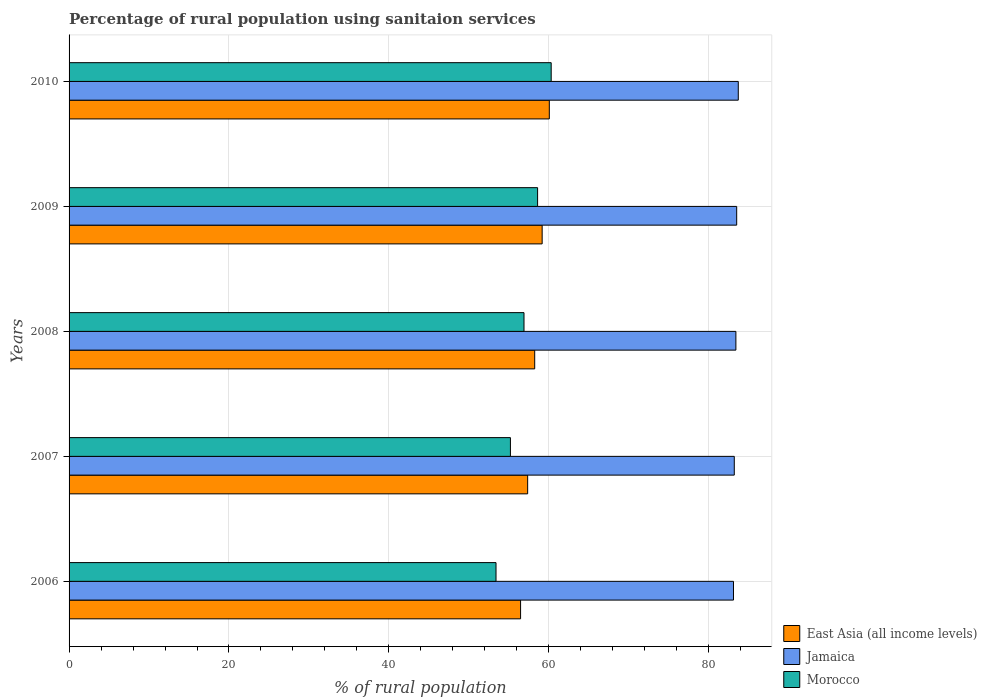How many different coloured bars are there?
Provide a succinct answer. 3. Are the number of bars on each tick of the Y-axis equal?
Give a very brief answer. Yes. How many bars are there on the 5th tick from the top?
Your response must be concise. 3. How many bars are there on the 4th tick from the bottom?
Ensure brevity in your answer.  3. In how many cases, is the number of bars for a given year not equal to the number of legend labels?
Your response must be concise. 0. What is the percentage of rural population using sanitaion services in Morocco in 2007?
Make the answer very short. 55.2. Across all years, what is the maximum percentage of rural population using sanitaion services in East Asia (all income levels)?
Your answer should be very brief. 60.07. Across all years, what is the minimum percentage of rural population using sanitaion services in East Asia (all income levels)?
Your answer should be compact. 56.47. In which year was the percentage of rural population using sanitaion services in Morocco maximum?
Give a very brief answer. 2010. What is the total percentage of rural population using sanitaion services in East Asia (all income levels) in the graph?
Make the answer very short. 291.3. What is the difference between the percentage of rural population using sanitaion services in Jamaica in 2006 and that in 2009?
Provide a short and direct response. -0.4. What is the difference between the percentage of rural population using sanitaion services in Morocco in 2009 and the percentage of rural population using sanitaion services in Jamaica in 2008?
Offer a terse response. -24.8. What is the average percentage of rural population using sanitaion services in Jamaica per year?
Provide a short and direct response. 83.38. In the year 2009, what is the difference between the percentage of rural population using sanitaion services in East Asia (all income levels) and percentage of rural population using sanitaion services in Morocco?
Offer a terse response. 0.57. In how many years, is the percentage of rural population using sanitaion services in Morocco greater than 16 %?
Your answer should be compact. 5. What is the ratio of the percentage of rural population using sanitaion services in Jamaica in 2007 to that in 2010?
Ensure brevity in your answer.  0.99. Is the percentage of rural population using sanitaion services in Jamaica in 2007 less than that in 2010?
Ensure brevity in your answer.  Yes. Is the difference between the percentage of rural population using sanitaion services in East Asia (all income levels) in 2006 and 2009 greater than the difference between the percentage of rural population using sanitaion services in Morocco in 2006 and 2009?
Offer a terse response. Yes. What is the difference between the highest and the second highest percentage of rural population using sanitaion services in East Asia (all income levels)?
Ensure brevity in your answer.  0.9. What is the difference between the highest and the lowest percentage of rural population using sanitaion services in Morocco?
Keep it short and to the point. 6.9. In how many years, is the percentage of rural population using sanitaion services in Morocco greater than the average percentage of rural population using sanitaion services in Morocco taken over all years?
Give a very brief answer. 3. Is the sum of the percentage of rural population using sanitaion services in East Asia (all income levels) in 2006 and 2010 greater than the maximum percentage of rural population using sanitaion services in Jamaica across all years?
Your answer should be compact. Yes. What does the 2nd bar from the top in 2010 represents?
Provide a succinct answer. Jamaica. What does the 1st bar from the bottom in 2008 represents?
Ensure brevity in your answer.  East Asia (all income levels). How many bars are there?
Give a very brief answer. 15. How many years are there in the graph?
Give a very brief answer. 5. Are the values on the major ticks of X-axis written in scientific E-notation?
Keep it short and to the point. No. Does the graph contain grids?
Offer a terse response. Yes. Where does the legend appear in the graph?
Provide a succinct answer. Bottom right. What is the title of the graph?
Give a very brief answer. Percentage of rural population using sanitaion services. Does "Low income" appear as one of the legend labels in the graph?
Your answer should be very brief. No. What is the label or title of the X-axis?
Ensure brevity in your answer.  % of rural population. What is the % of rural population of East Asia (all income levels) in 2006?
Make the answer very short. 56.47. What is the % of rural population in Jamaica in 2006?
Your response must be concise. 83.1. What is the % of rural population in Morocco in 2006?
Make the answer very short. 53.4. What is the % of rural population in East Asia (all income levels) in 2007?
Your answer should be very brief. 57.36. What is the % of rural population of Jamaica in 2007?
Your answer should be very brief. 83.2. What is the % of rural population of Morocco in 2007?
Provide a short and direct response. 55.2. What is the % of rural population of East Asia (all income levels) in 2008?
Provide a short and direct response. 58.24. What is the % of rural population of Jamaica in 2008?
Offer a terse response. 83.4. What is the % of rural population in Morocco in 2008?
Your answer should be very brief. 56.9. What is the % of rural population in East Asia (all income levels) in 2009?
Make the answer very short. 59.17. What is the % of rural population of Jamaica in 2009?
Your response must be concise. 83.5. What is the % of rural population of Morocco in 2009?
Offer a very short reply. 58.6. What is the % of rural population of East Asia (all income levels) in 2010?
Give a very brief answer. 60.07. What is the % of rural population in Jamaica in 2010?
Offer a terse response. 83.7. What is the % of rural population in Morocco in 2010?
Your answer should be compact. 60.3. Across all years, what is the maximum % of rural population of East Asia (all income levels)?
Your answer should be compact. 60.07. Across all years, what is the maximum % of rural population in Jamaica?
Ensure brevity in your answer.  83.7. Across all years, what is the maximum % of rural population in Morocco?
Give a very brief answer. 60.3. Across all years, what is the minimum % of rural population in East Asia (all income levels)?
Make the answer very short. 56.47. Across all years, what is the minimum % of rural population of Jamaica?
Offer a very short reply. 83.1. Across all years, what is the minimum % of rural population in Morocco?
Make the answer very short. 53.4. What is the total % of rural population in East Asia (all income levels) in the graph?
Your response must be concise. 291.3. What is the total % of rural population of Jamaica in the graph?
Keep it short and to the point. 416.9. What is the total % of rural population of Morocco in the graph?
Give a very brief answer. 284.4. What is the difference between the % of rural population in East Asia (all income levels) in 2006 and that in 2007?
Offer a very short reply. -0.89. What is the difference between the % of rural population in East Asia (all income levels) in 2006 and that in 2008?
Provide a short and direct response. -1.77. What is the difference between the % of rural population of Jamaica in 2006 and that in 2008?
Provide a succinct answer. -0.3. What is the difference between the % of rural population of East Asia (all income levels) in 2006 and that in 2009?
Ensure brevity in your answer.  -2.7. What is the difference between the % of rural population of Jamaica in 2006 and that in 2009?
Ensure brevity in your answer.  -0.4. What is the difference between the % of rural population in Morocco in 2006 and that in 2009?
Offer a very short reply. -5.2. What is the difference between the % of rural population in East Asia (all income levels) in 2006 and that in 2010?
Provide a short and direct response. -3.59. What is the difference between the % of rural population in East Asia (all income levels) in 2007 and that in 2008?
Provide a short and direct response. -0.88. What is the difference between the % of rural population of East Asia (all income levels) in 2007 and that in 2009?
Your response must be concise. -1.81. What is the difference between the % of rural population in East Asia (all income levels) in 2007 and that in 2010?
Ensure brevity in your answer.  -2.71. What is the difference between the % of rural population in Jamaica in 2007 and that in 2010?
Make the answer very short. -0.5. What is the difference between the % of rural population in Morocco in 2007 and that in 2010?
Your response must be concise. -5.1. What is the difference between the % of rural population of East Asia (all income levels) in 2008 and that in 2009?
Give a very brief answer. -0.93. What is the difference between the % of rural population of Morocco in 2008 and that in 2009?
Keep it short and to the point. -1.7. What is the difference between the % of rural population in East Asia (all income levels) in 2008 and that in 2010?
Provide a succinct answer. -1.83. What is the difference between the % of rural population of East Asia (all income levels) in 2009 and that in 2010?
Offer a terse response. -0.9. What is the difference between the % of rural population in Jamaica in 2009 and that in 2010?
Offer a very short reply. -0.2. What is the difference between the % of rural population of East Asia (all income levels) in 2006 and the % of rural population of Jamaica in 2007?
Make the answer very short. -26.73. What is the difference between the % of rural population of East Asia (all income levels) in 2006 and the % of rural population of Morocco in 2007?
Your answer should be very brief. 1.27. What is the difference between the % of rural population of Jamaica in 2006 and the % of rural population of Morocco in 2007?
Your answer should be very brief. 27.9. What is the difference between the % of rural population of East Asia (all income levels) in 2006 and the % of rural population of Jamaica in 2008?
Provide a succinct answer. -26.93. What is the difference between the % of rural population in East Asia (all income levels) in 2006 and the % of rural population in Morocco in 2008?
Your answer should be very brief. -0.43. What is the difference between the % of rural population in Jamaica in 2006 and the % of rural population in Morocco in 2008?
Provide a succinct answer. 26.2. What is the difference between the % of rural population in East Asia (all income levels) in 2006 and the % of rural population in Jamaica in 2009?
Keep it short and to the point. -27.03. What is the difference between the % of rural population of East Asia (all income levels) in 2006 and the % of rural population of Morocco in 2009?
Your answer should be very brief. -2.13. What is the difference between the % of rural population of Jamaica in 2006 and the % of rural population of Morocco in 2009?
Your answer should be compact. 24.5. What is the difference between the % of rural population of East Asia (all income levels) in 2006 and the % of rural population of Jamaica in 2010?
Provide a short and direct response. -27.23. What is the difference between the % of rural population in East Asia (all income levels) in 2006 and the % of rural population in Morocco in 2010?
Your answer should be very brief. -3.83. What is the difference between the % of rural population of Jamaica in 2006 and the % of rural population of Morocco in 2010?
Offer a terse response. 22.8. What is the difference between the % of rural population in East Asia (all income levels) in 2007 and the % of rural population in Jamaica in 2008?
Make the answer very short. -26.04. What is the difference between the % of rural population of East Asia (all income levels) in 2007 and the % of rural population of Morocco in 2008?
Your answer should be very brief. 0.46. What is the difference between the % of rural population in Jamaica in 2007 and the % of rural population in Morocco in 2008?
Your response must be concise. 26.3. What is the difference between the % of rural population in East Asia (all income levels) in 2007 and the % of rural population in Jamaica in 2009?
Your answer should be compact. -26.14. What is the difference between the % of rural population in East Asia (all income levels) in 2007 and the % of rural population in Morocco in 2009?
Keep it short and to the point. -1.24. What is the difference between the % of rural population of Jamaica in 2007 and the % of rural population of Morocco in 2009?
Offer a very short reply. 24.6. What is the difference between the % of rural population in East Asia (all income levels) in 2007 and the % of rural population in Jamaica in 2010?
Ensure brevity in your answer.  -26.34. What is the difference between the % of rural population in East Asia (all income levels) in 2007 and the % of rural population in Morocco in 2010?
Keep it short and to the point. -2.94. What is the difference between the % of rural population of Jamaica in 2007 and the % of rural population of Morocco in 2010?
Give a very brief answer. 22.9. What is the difference between the % of rural population in East Asia (all income levels) in 2008 and the % of rural population in Jamaica in 2009?
Provide a succinct answer. -25.26. What is the difference between the % of rural population of East Asia (all income levels) in 2008 and the % of rural population of Morocco in 2009?
Make the answer very short. -0.36. What is the difference between the % of rural population of Jamaica in 2008 and the % of rural population of Morocco in 2009?
Keep it short and to the point. 24.8. What is the difference between the % of rural population of East Asia (all income levels) in 2008 and the % of rural population of Jamaica in 2010?
Provide a succinct answer. -25.46. What is the difference between the % of rural population in East Asia (all income levels) in 2008 and the % of rural population in Morocco in 2010?
Give a very brief answer. -2.06. What is the difference between the % of rural population of Jamaica in 2008 and the % of rural population of Morocco in 2010?
Make the answer very short. 23.1. What is the difference between the % of rural population of East Asia (all income levels) in 2009 and the % of rural population of Jamaica in 2010?
Offer a very short reply. -24.53. What is the difference between the % of rural population of East Asia (all income levels) in 2009 and the % of rural population of Morocco in 2010?
Your response must be concise. -1.13. What is the difference between the % of rural population of Jamaica in 2009 and the % of rural population of Morocco in 2010?
Your response must be concise. 23.2. What is the average % of rural population of East Asia (all income levels) per year?
Ensure brevity in your answer.  58.26. What is the average % of rural population of Jamaica per year?
Provide a succinct answer. 83.38. What is the average % of rural population in Morocco per year?
Your response must be concise. 56.88. In the year 2006, what is the difference between the % of rural population of East Asia (all income levels) and % of rural population of Jamaica?
Provide a succinct answer. -26.63. In the year 2006, what is the difference between the % of rural population in East Asia (all income levels) and % of rural population in Morocco?
Your response must be concise. 3.07. In the year 2006, what is the difference between the % of rural population in Jamaica and % of rural population in Morocco?
Your answer should be very brief. 29.7. In the year 2007, what is the difference between the % of rural population in East Asia (all income levels) and % of rural population in Jamaica?
Provide a short and direct response. -25.84. In the year 2007, what is the difference between the % of rural population in East Asia (all income levels) and % of rural population in Morocco?
Offer a very short reply. 2.16. In the year 2008, what is the difference between the % of rural population of East Asia (all income levels) and % of rural population of Jamaica?
Provide a short and direct response. -25.16. In the year 2008, what is the difference between the % of rural population in East Asia (all income levels) and % of rural population in Morocco?
Your response must be concise. 1.34. In the year 2008, what is the difference between the % of rural population in Jamaica and % of rural population in Morocco?
Your response must be concise. 26.5. In the year 2009, what is the difference between the % of rural population in East Asia (all income levels) and % of rural population in Jamaica?
Give a very brief answer. -24.33. In the year 2009, what is the difference between the % of rural population of East Asia (all income levels) and % of rural population of Morocco?
Provide a short and direct response. 0.57. In the year 2009, what is the difference between the % of rural population in Jamaica and % of rural population in Morocco?
Provide a succinct answer. 24.9. In the year 2010, what is the difference between the % of rural population in East Asia (all income levels) and % of rural population in Jamaica?
Give a very brief answer. -23.63. In the year 2010, what is the difference between the % of rural population in East Asia (all income levels) and % of rural population in Morocco?
Your response must be concise. -0.23. In the year 2010, what is the difference between the % of rural population of Jamaica and % of rural population of Morocco?
Provide a short and direct response. 23.4. What is the ratio of the % of rural population in East Asia (all income levels) in 2006 to that in 2007?
Provide a short and direct response. 0.98. What is the ratio of the % of rural population of Jamaica in 2006 to that in 2007?
Your response must be concise. 1. What is the ratio of the % of rural population of Morocco in 2006 to that in 2007?
Give a very brief answer. 0.97. What is the ratio of the % of rural population in East Asia (all income levels) in 2006 to that in 2008?
Ensure brevity in your answer.  0.97. What is the ratio of the % of rural population in Morocco in 2006 to that in 2008?
Make the answer very short. 0.94. What is the ratio of the % of rural population in East Asia (all income levels) in 2006 to that in 2009?
Keep it short and to the point. 0.95. What is the ratio of the % of rural population of Jamaica in 2006 to that in 2009?
Your answer should be compact. 1. What is the ratio of the % of rural population in Morocco in 2006 to that in 2009?
Make the answer very short. 0.91. What is the ratio of the % of rural population in East Asia (all income levels) in 2006 to that in 2010?
Give a very brief answer. 0.94. What is the ratio of the % of rural population of Morocco in 2006 to that in 2010?
Your answer should be compact. 0.89. What is the ratio of the % of rural population of East Asia (all income levels) in 2007 to that in 2008?
Make the answer very short. 0.98. What is the ratio of the % of rural population in Jamaica in 2007 to that in 2008?
Your answer should be very brief. 1. What is the ratio of the % of rural population in Morocco in 2007 to that in 2008?
Offer a very short reply. 0.97. What is the ratio of the % of rural population of East Asia (all income levels) in 2007 to that in 2009?
Your answer should be very brief. 0.97. What is the ratio of the % of rural population in Jamaica in 2007 to that in 2009?
Your response must be concise. 1. What is the ratio of the % of rural population in Morocco in 2007 to that in 2009?
Make the answer very short. 0.94. What is the ratio of the % of rural population of East Asia (all income levels) in 2007 to that in 2010?
Offer a terse response. 0.95. What is the ratio of the % of rural population in Morocco in 2007 to that in 2010?
Give a very brief answer. 0.92. What is the ratio of the % of rural population in East Asia (all income levels) in 2008 to that in 2009?
Make the answer very short. 0.98. What is the ratio of the % of rural population of East Asia (all income levels) in 2008 to that in 2010?
Offer a very short reply. 0.97. What is the ratio of the % of rural population of Jamaica in 2008 to that in 2010?
Offer a terse response. 1. What is the ratio of the % of rural population in Morocco in 2008 to that in 2010?
Ensure brevity in your answer.  0.94. What is the ratio of the % of rural population of East Asia (all income levels) in 2009 to that in 2010?
Ensure brevity in your answer.  0.99. What is the ratio of the % of rural population of Jamaica in 2009 to that in 2010?
Ensure brevity in your answer.  1. What is the ratio of the % of rural population in Morocco in 2009 to that in 2010?
Ensure brevity in your answer.  0.97. What is the difference between the highest and the second highest % of rural population of East Asia (all income levels)?
Offer a terse response. 0.9. What is the difference between the highest and the second highest % of rural population of Morocco?
Keep it short and to the point. 1.7. What is the difference between the highest and the lowest % of rural population of East Asia (all income levels)?
Offer a terse response. 3.59. What is the difference between the highest and the lowest % of rural population of Morocco?
Keep it short and to the point. 6.9. 